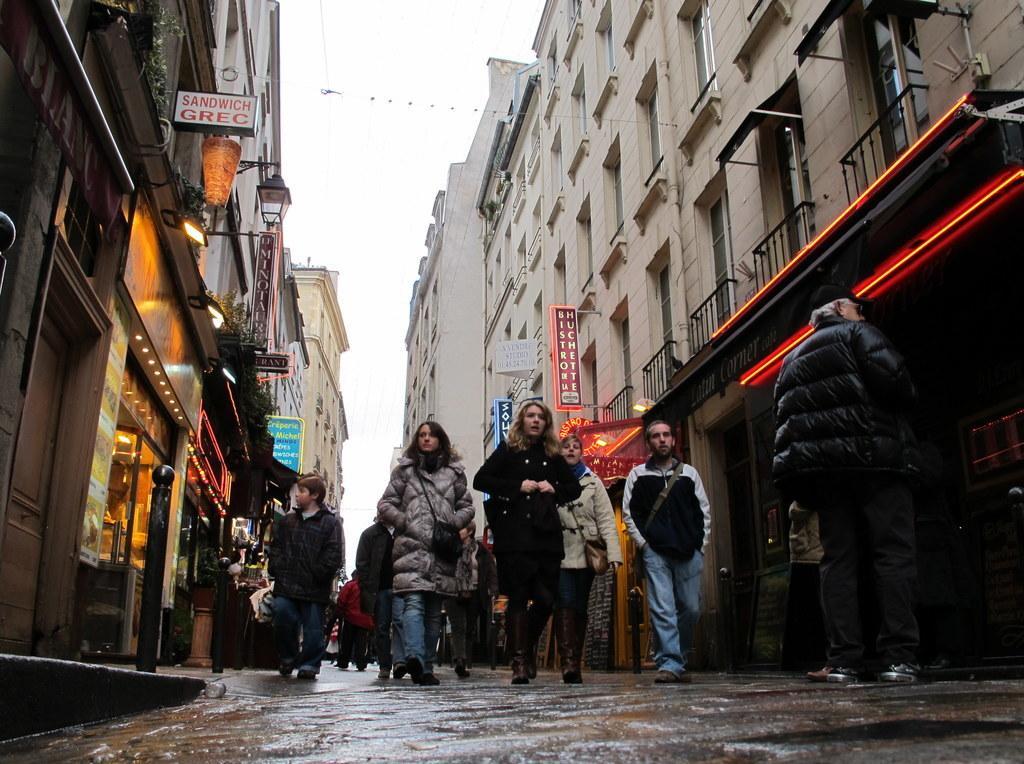In one or two sentences, can you explain what this image depicts? In this image I can see number of people are standing. I can see most of them are wearing jackets. In the background I can see number of buildings, number of boards, a light and on these words I can see something is written. I can also see few more lights over here. 